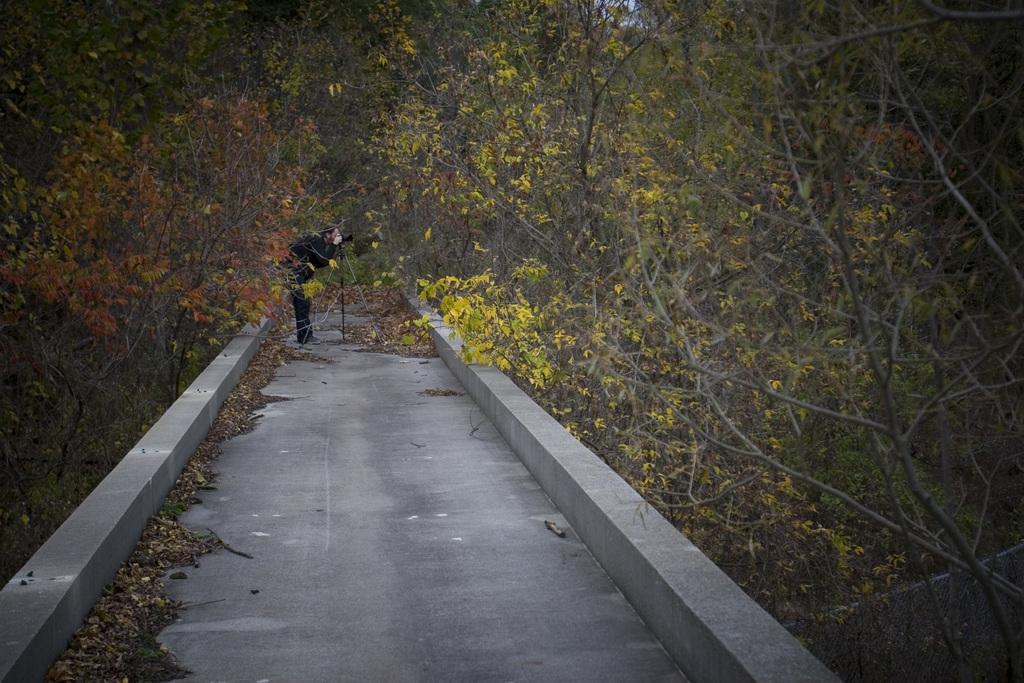Could you give a brief overview of what you see in this image? In the center of the image we can see a person standing on a pathway holding a stick. We can also see a group of trees and some dried leaves. 